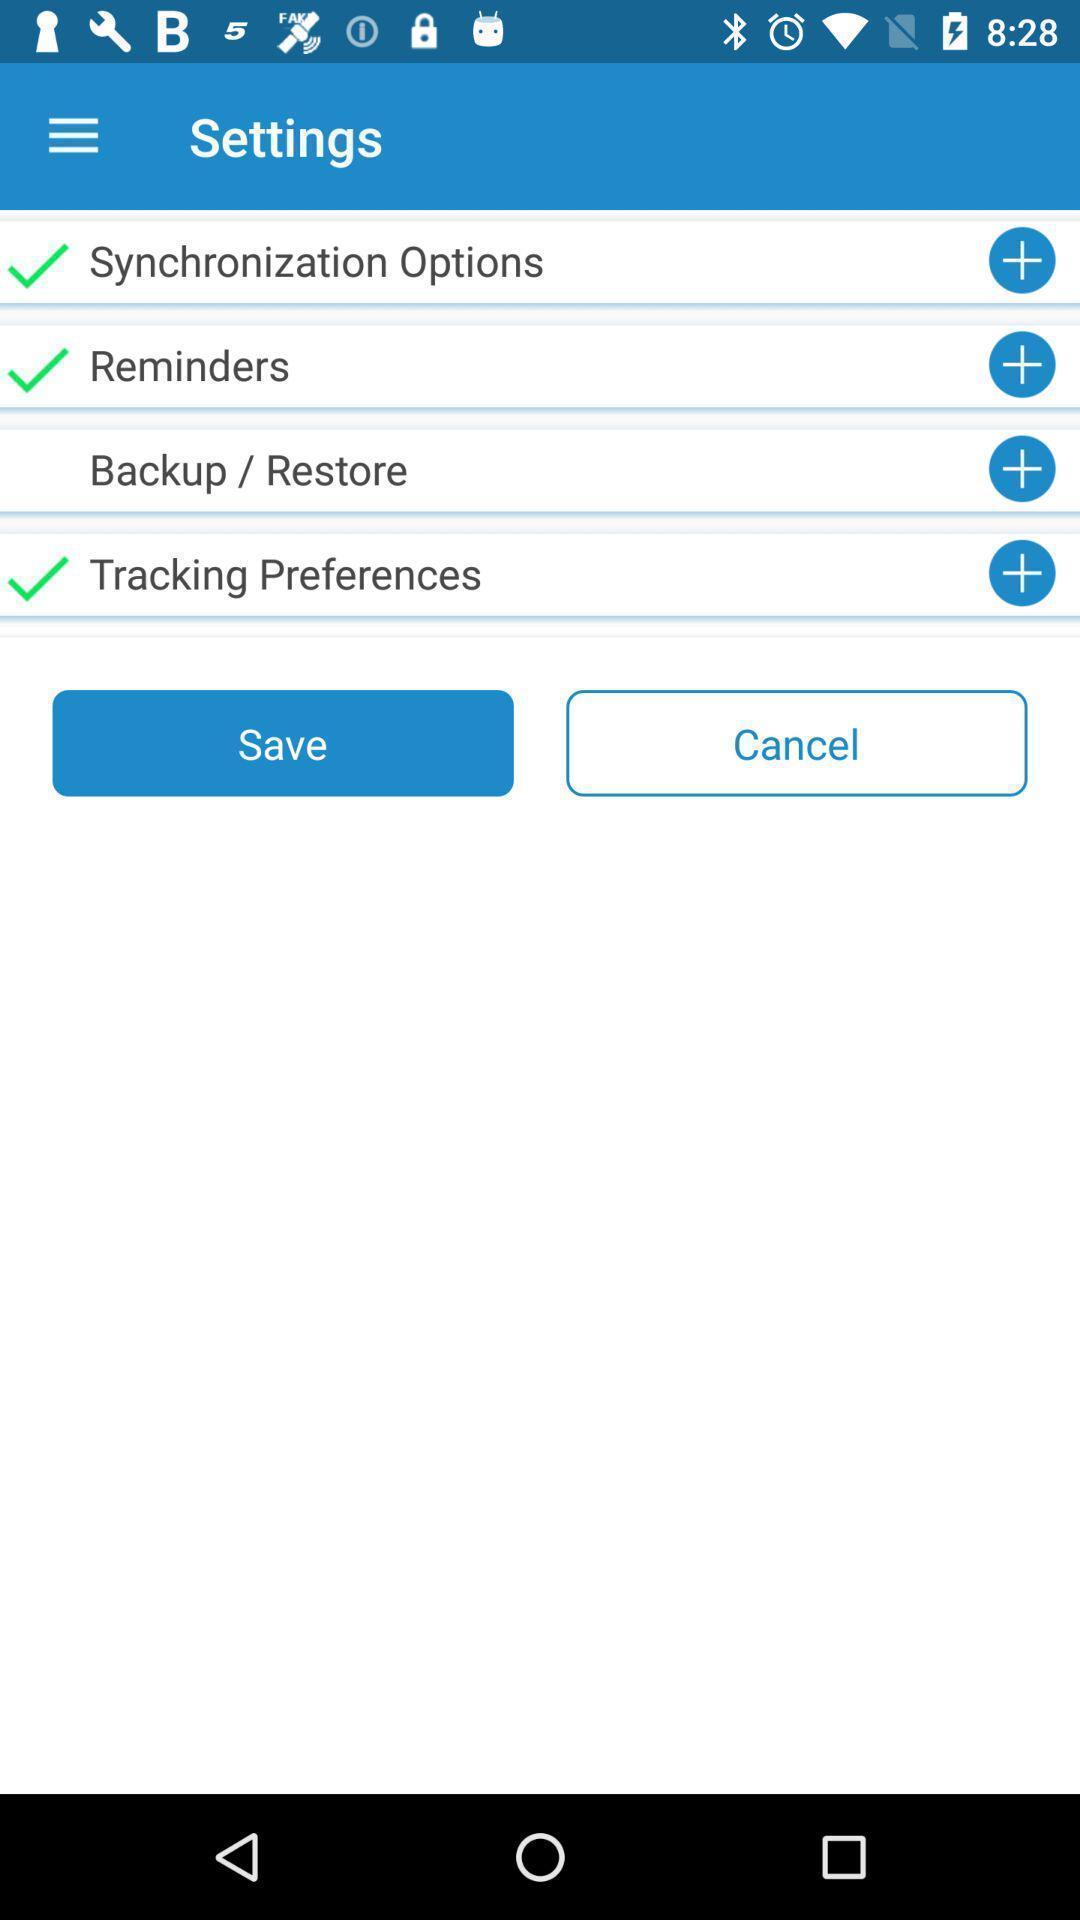What is the overall content of this screenshot? Settings page. 